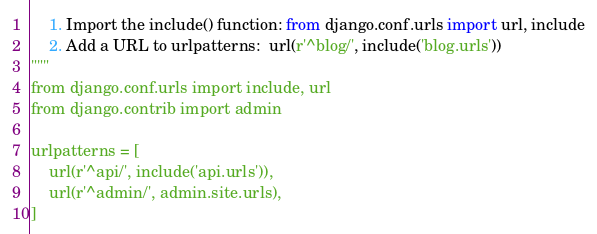Convert code to text. <code><loc_0><loc_0><loc_500><loc_500><_Python_>    1. Import the include() function: from django.conf.urls import url, include
    2. Add a URL to urlpatterns:  url(r'^blog/', include('blog.urls'))
"""
from django.conf.urls import include, url
from django.contrib import admin

urlpatterns = [
    url(r'^api/', include('api.urls')),
    url(r'^admin/', admin.site.urls),
]
</code> 